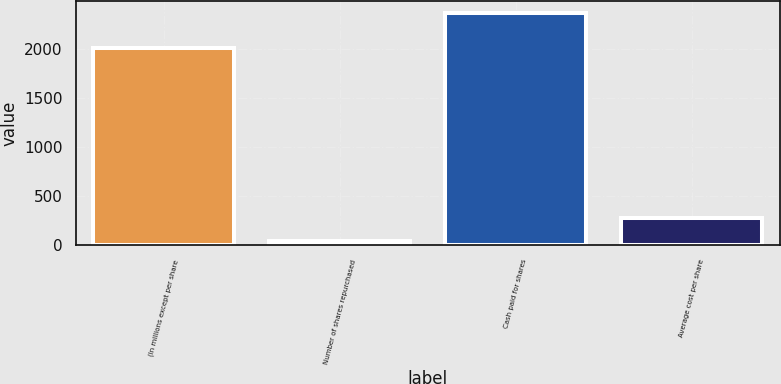Convert chart to OTSL. <chart><loc_0><loc_0><loc_500><loc_500><bar_chart><fcel>(In millions except per share<fcel>Number of shares repurchased<fcel>Cash paid for shares<fcel>Average cost per share<nl><fcel>2017<fcel>44<fcel>2372<fcel>276.8<nl></chart> 